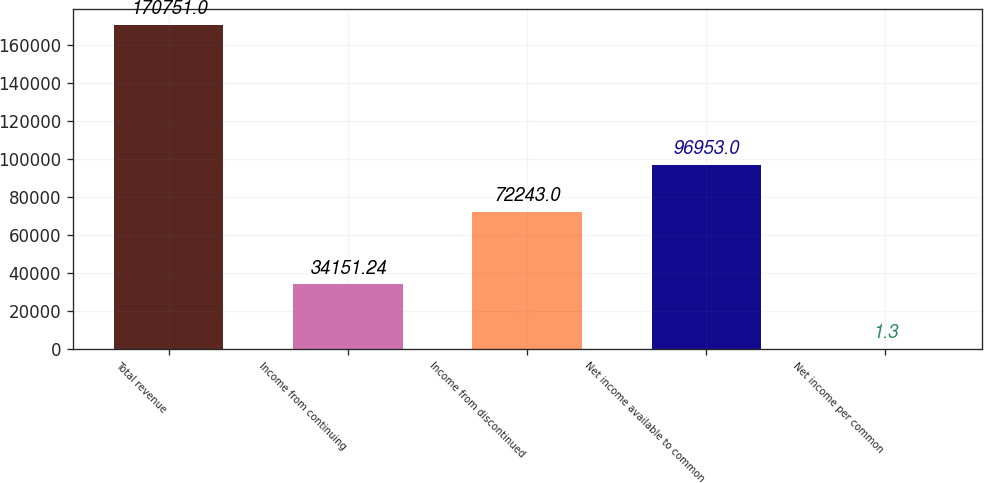Convert chart to OTSL. <chart><loc_0><loc_0><loc_500><loc_500><bar_chart><fcel>Total revenue<fcel>Income from continuing<fcel>Income from discontinued<fcel>Net income available to common<fcel>Net income per common<nl><fcel>170751<fcel>34151.2<fcel>72243<fcel>96953<fcel>1.3<nl></chart> 